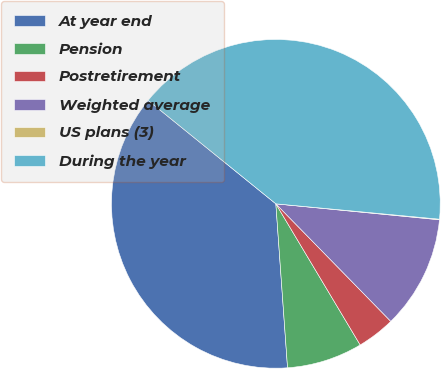<chart> <loc_0><loc_0><loc_500><loc_500><pie_chart><fcel>At year end<fcel>Pension<fcel>Postretirement<fcel>Weighted average<fcel>US plans (3)<fcel>During the year<nl><fcel>36.97%<fcel>7.44%<fcel>3.75%<fcel>11.13%<fcel>0.06%<fcel>40.66%<nl></chart> 